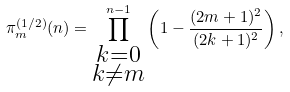<formula> <loc_0><loc_0><loc_500><loc_500>\pi _ { m } ^ { ( 1 / 2 ) } ( n ) = \prod _ { \substack { k = 0 \\ k { \not = } m } } ^ { n - 1 } \left ( 1 - \frac { ( 2 m + 1 ) ^ { 2 } } { ( 2 k + 1 ) ^ { 2 } } \right ) ,</formula> 